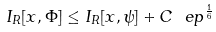<formula> <loc_0><loc_0><loc_500><loc_500>I _ { R } [ x , \Phi ] \leq I _ { R } [ x , \psi ] + C \ e p ^ { \frac { 1 } { 6 } }</formula> 